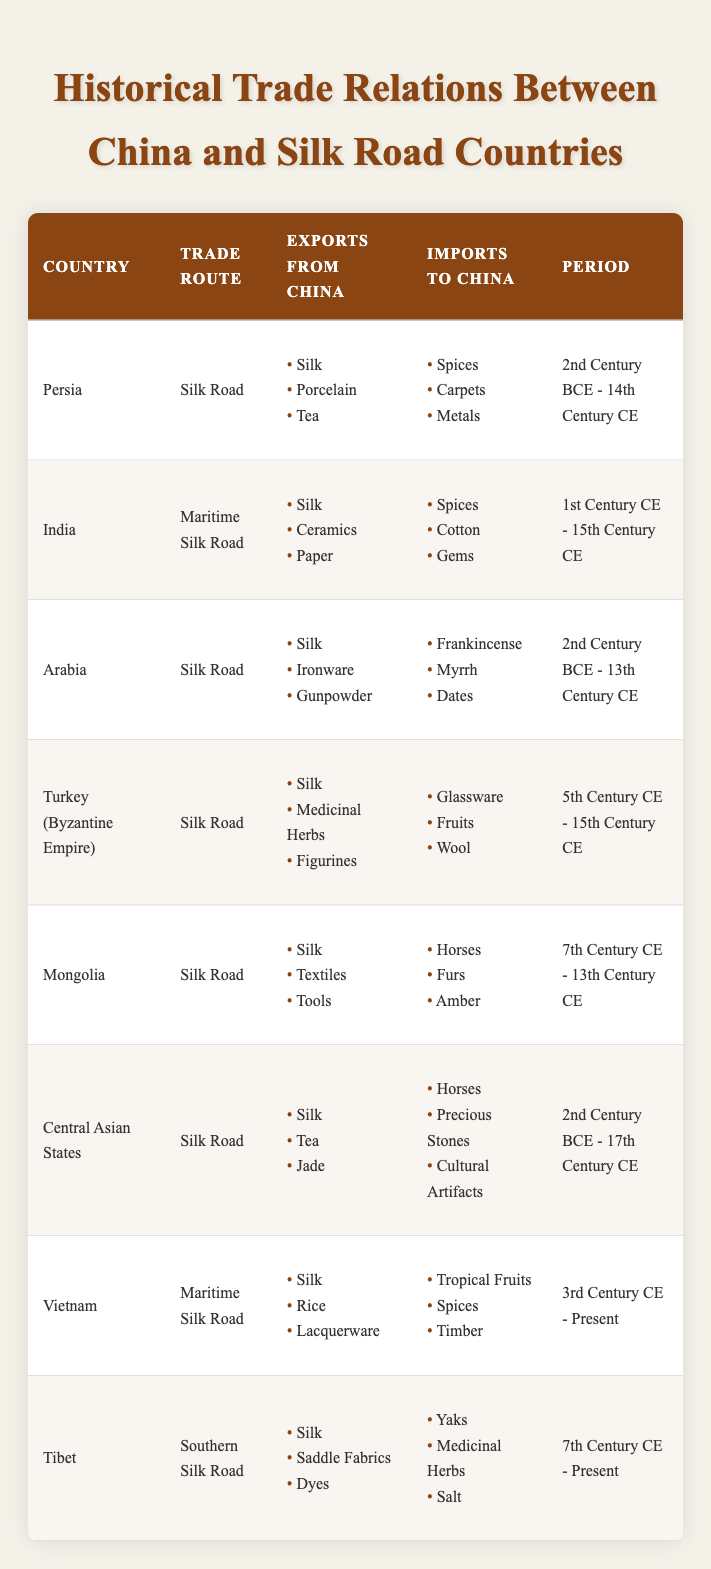What are the major goods exported from China to Persia? The table lists the major goods exported from China to each country. For Persia, the goods are Silk, Porcelain, and Tea.
Answer: Silk, Porcelain, Tea Which trade route was used for trade with Mongolia? According to the table, Mongolia was connected to China via the Silk Road.
Answer: Silk Road Did China import wool from Turkey? The table shows that China imported Glassware, Fruits, and Wool from Turkey (Byzantine Empire), therefore yes it did.
Answer: Yes What are the goods that China imported from Vietnam? Referring to the table, Vietnam exported Tropical Fruits, Spices, and Timber to China.
Answer: Tropical Fruits, Spices, Timber How many countries traded along the Maritime Silk Road? The table lists India and Vietnam as the countries that traded along the Maritime Silk Road, which totals two countries.
Answer: 2 Which country had an export period that started in the 3rd Century CE? The table indicates that Vietnam began exporting during the 3rd Century CE, making it the relevant country.
Answer: Vietnam What is the difference in the export periods between India and Central Asian States? India’s export period ends in the 15th Century CE, while Central Asian States’ period continues to the 17th Century CE. Thus, the difference is 2 centuries.
Answer: 2 centuries List all major goods imported by China from Arabia. The table indicates that China imported Frankincense, Myrrh, and Dates from Arabia.
Answer: Frankincense, Myrrh, Dates Which country exported medicinal herbs to China and during what period? The table shows that Turkey (Byzantine Empire) exported Medicinal Herbs to China between the 5th Century CE and the 15th Century CE.
Answer: Turkey (Byzantine Empire), 5th Century CE - 15th Century CE Considering all countries, what are the major items exported from China that are repeatedly listed? Analyzing the table, Silk is mentioned as an export to all countries. Tea is listed for Persia and Central Asian States.
Answer: Silk Which country had the longest continuous trading period listed in the table? Central Asian States have a trading period that spans from the 2nd Century BCE to the 17th Century CE, which is the longest duration.
Answer: Central Asian States 